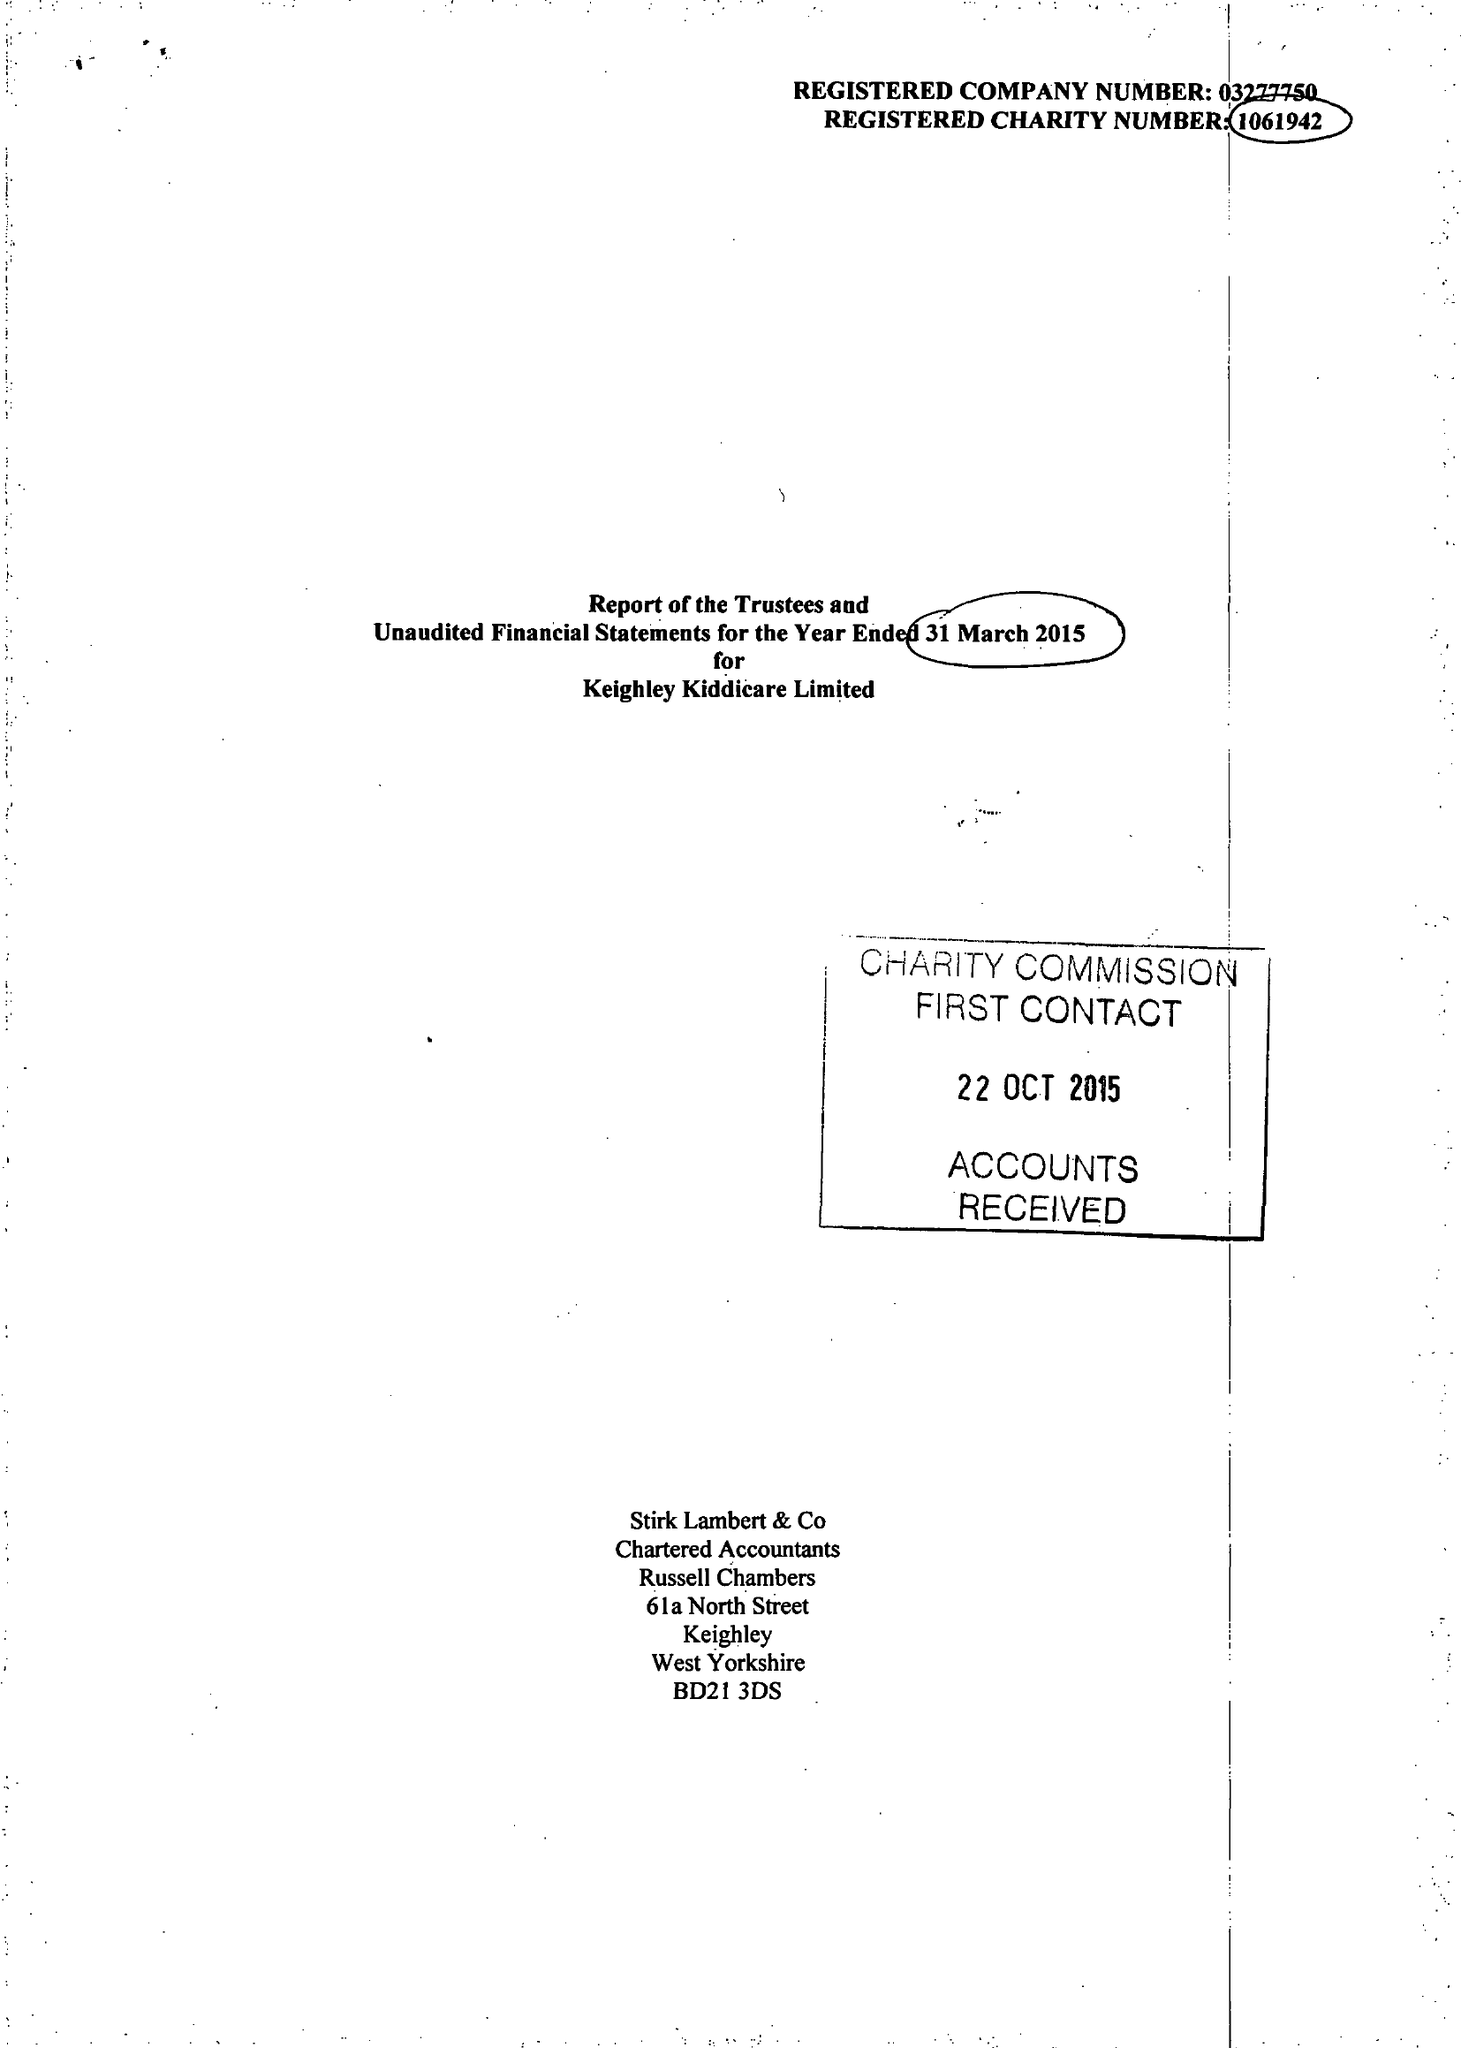What is the value for the charity_name?
Answer the question using a single word or phrase. Keighley Kiddicare Ltd. 